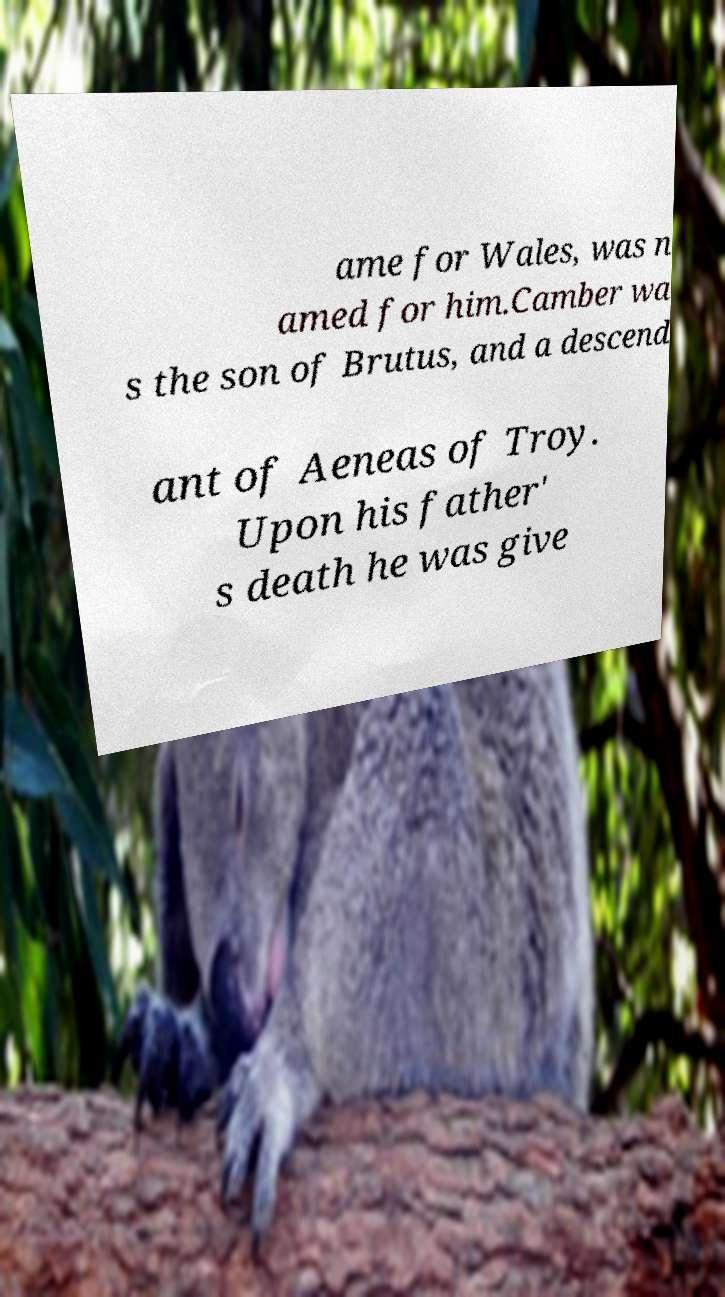Could you extract and type out the text from this image? ame for Wales, was n amed for him.Camber wa s the son of Brutus, and a descend ant of Aeneas of Troy. Upon his father' s death he was give 